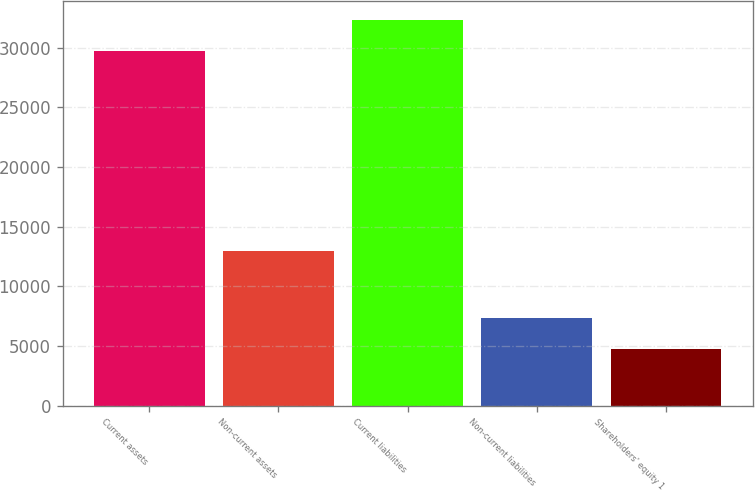<chart> <loc_0><loc_0><loc_500><loc_500><bar_chart><fcel>Current assets<fcel>Non-current assets<fcel>Current liabilities<fcel>Non-current liabilities<fcel>Shareholders' equity 1<nl><fcel>29707<fcel>12999<fcel>32284.4<fcel>7362.4<fcel>4785<nl></chart> 